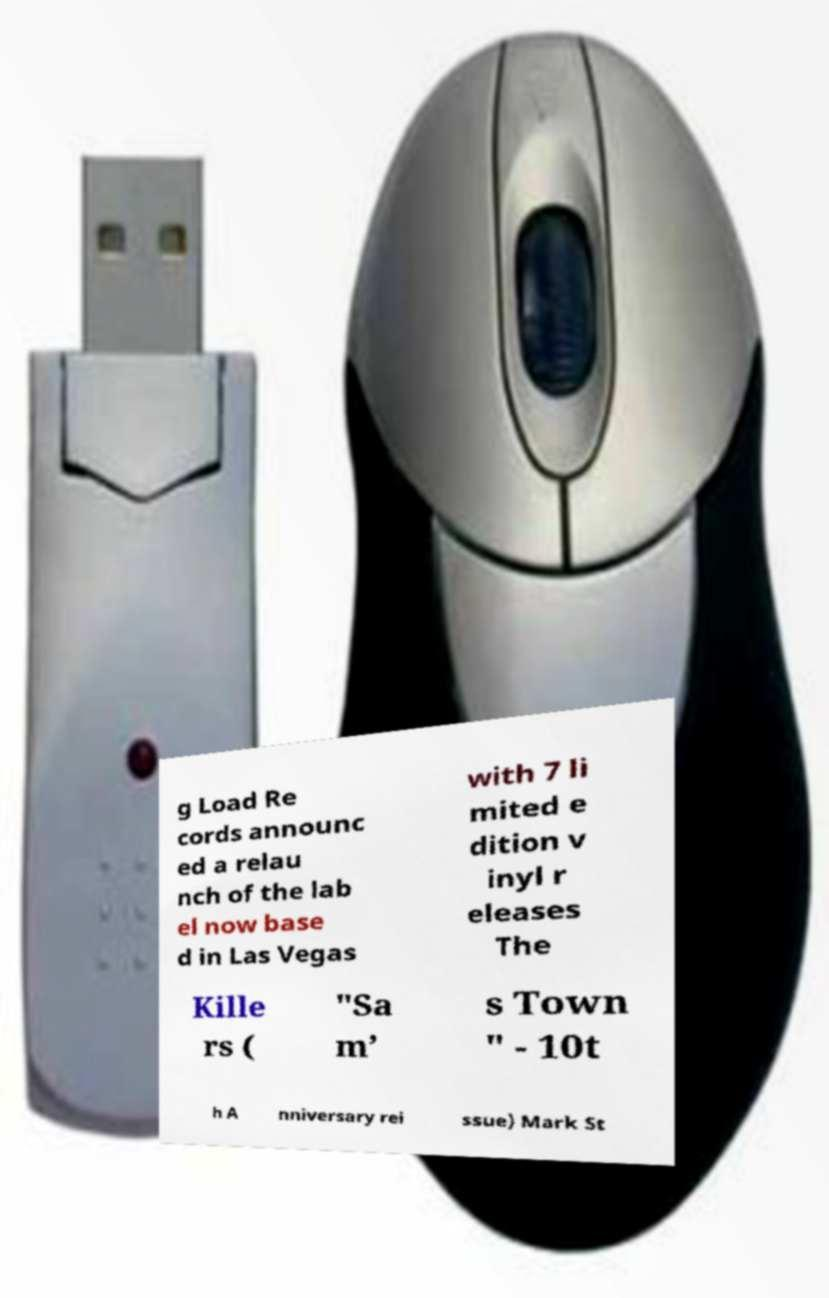Could you assist in decoding the text presented in this image and type it out clearly? g Load Re cords announc ed a relau nch of the lab el now base d in Las Vegas with 7 li mited e dition v inyl r eleases The Kille rs ( "Sa m’ s Town " - 10t h A nniversary rei ssue) Mark St 